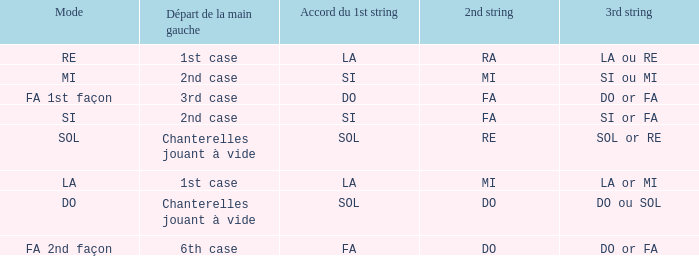For the 2nd string of Ra what is the Depart de la main gauche? 1st case. 